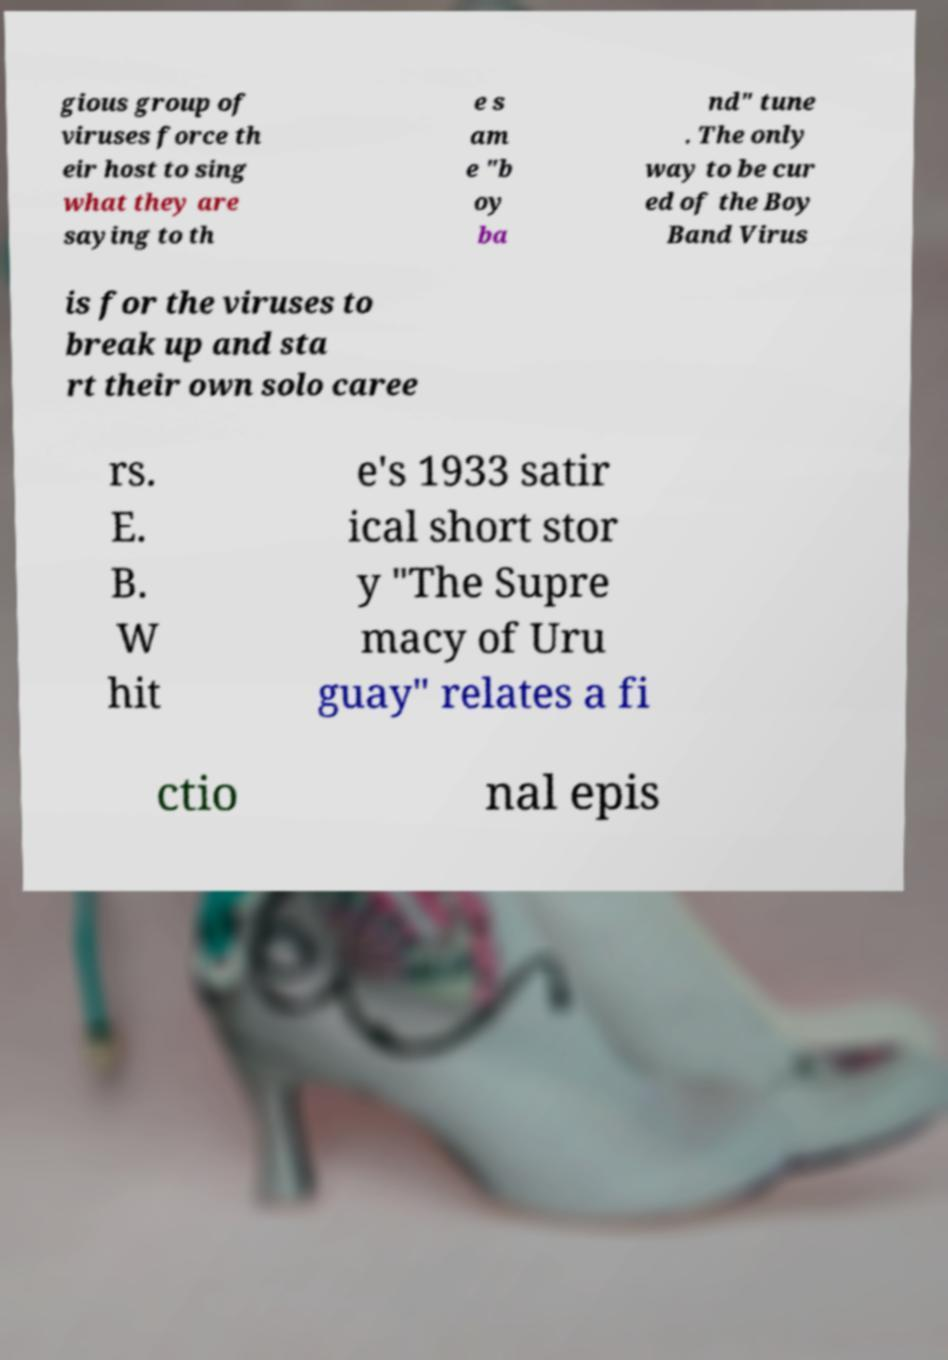There's text embedded in this image that I need extracted. Can you transcribe it verbatim? gious group of viruses force th eir host to sing what they are saying to th e s am e "b oy ba nd" tune . The only way to be cur ed of the Boy Band Virus is for the viruses to break up and sta rt their own solo caree rs. E. B. W hit e's 1933 satir ical short stor y "The Supre macy of Uru guay" relates a fi ctio nal epis 